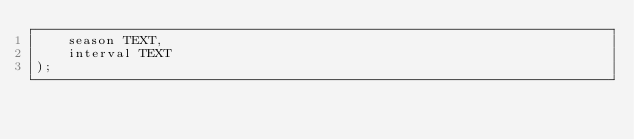<code> <loc_0><loc_0><loc_500><loc_500><_SQL_>	season TEXT,
	interval TEXT
);

</code> 